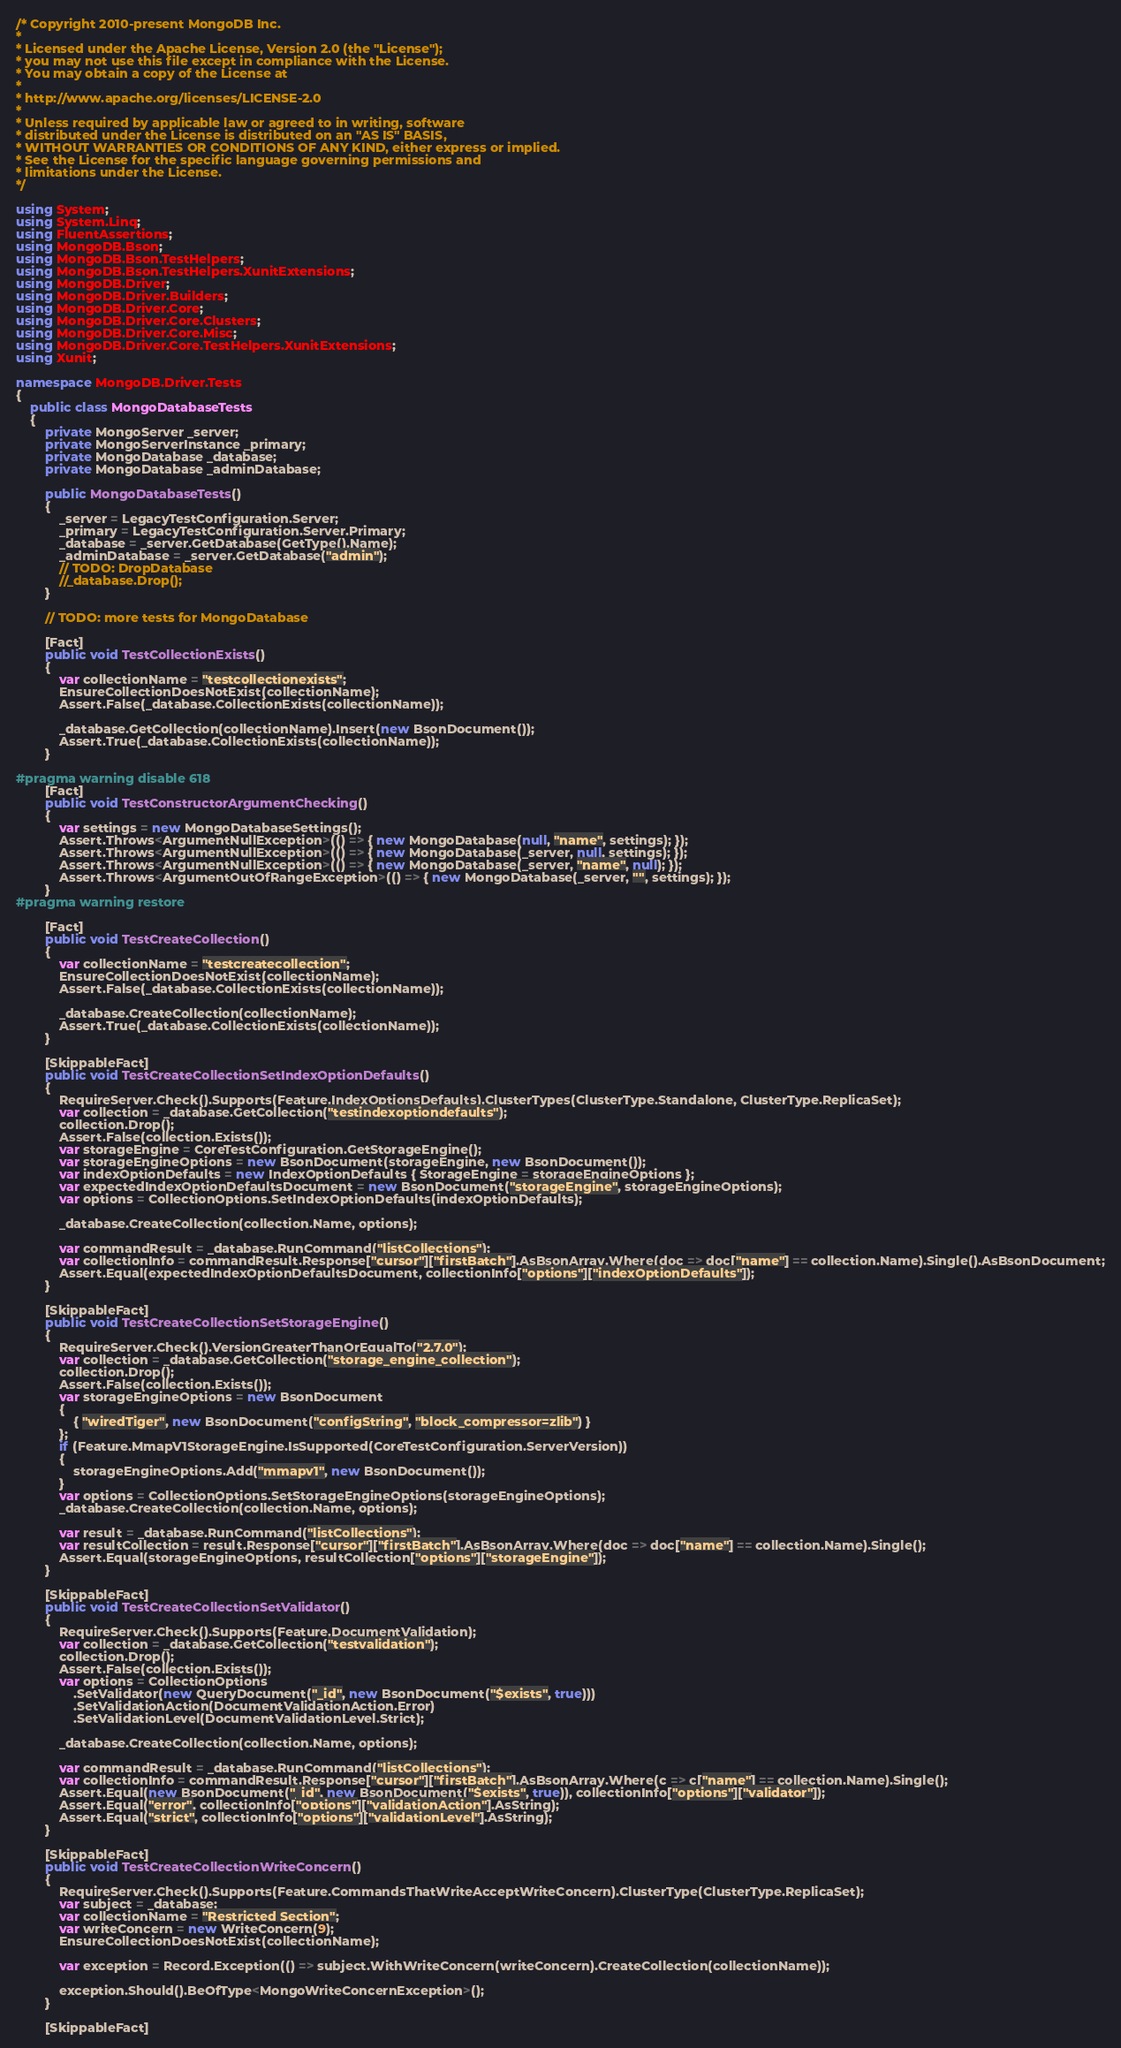Convert code to text. <code><loc_0><loc_0><loc_500><loc_500><_C#_>/* Copyright 2010-present MongoDB Inc.
*
* Licensed under the Apache License, Version 2.0 (the "License");
* you may not use this file except in compliance with the License.
* You may obtain a copy of the License at
*
* http://www.apache.org/licenses/LICENSE-2.0
*
* Unless required by applicable law or agreed to in writing, software
* distributed under the License is distributed on an "AS IS" BASIS,
* WITHOUT WARRANTIES OR CONDITIONS OF ANY KIND, either express or implied.
* See the License for the specific language governing permissions and
* limitations under the License.
*/

using System;
using System.Linq;
using FluentAssertions;
using MongoDB.Bson;
using MongoDB.Bson.TestHelpers;
using MongoDB.Bson.TestHelpers.XunitExtensions;
using MongoDB.Driver;
using MongoDB.Driver.Builders;
using MongoDB.Driver.Core;
using MongoDB.Driver.Core.Clusters;
using MongoDB.Driver.Core.Misc;
using MongoDB.Driver.Core.TestHelpers.XunitExtensions;
using Xunit;

namespace MongoDB.Driver.Tests
{
    public class MongoDatabaseTests
    {
        private MongoServer _server;
        private MongoServerInstance _primary;
        private MongoDatabase _database;
        private MongoDatabase _adminDatabase;

        public MongoDatabaseTests()
        {
            _server = LegacyTestConfiguration.Server;
            _primary = LegacyTestConfiguration.Server.Primary;
            _database = _server.GetDatabase(GetType().Name);
            _adminDatabase = _server.GetDatabase("admin");
            // TODO: DropDatabase
            //_database.Drop();
        }

        // TODO: more tests for MongoDatabase

        [Fact]
        public void TestCollectionExists()
        {
            var collectionName = "testcollectionexists";
            EnsureCollectionDoesNotExist(collectionName);            
            Assert.False(_database.CollectionExists(collectionName));

            _database.GetCollection(collectionName).Insert(new BsonDocument());
            Assert.True(_database.CollectionExists(collectionName));
        }

#pragma warning disable 618
        [Fact]
        public void TestConstructorArgumentChecking()
        {
            var settings = new MongoDatabaseSettings();
            Assert.Throws<ArgumentNullException>(() => { new MongoDatabase(null, "name", settings); });
            Assert.Throws<ArgumentNullException>(() => { new MongoDatabase(_server, null, settings); });
            Assert.Throws<ArgumentNullException>(() => { new MongoDatabase(_server, "name", null); });
            Assert.Throws<ArgumentOutOfRangeException>(() => { new MongoDatabase(_server, "", settings); });
        }
#pragma warning restore

        [Fact]
        public void TestCreateCollection()
        {
            var collectionName = "testcreatecollection";
            EnsureCollectionDoesNotExist(collectionName);
            Assert.False(_database.CollectionExists(collectionName));

            _database.CreateCollection(collectionName);
            Assert.True(_database.CollectionExists(collectionName));
        }

        [SkippableFact]
        public void TestCreateCollectionSetIndexOptionDefaults()
        {
            RequireServer.Check().Supports(Feature.IndexOptionsDefaults).ClusterTypes(ClusterType.Standalone, ClusterType.ReplicaSet);
            var collection = _database.GetCollection("testindexoptiondefaults");
            collection.Drop();
            Assert.False(collection.Exists());
            var storageEngine = CoreTestConfiguration.GetStorageEngine();
            var storageEngineOptions = new BsonDocument(storageEngine, new BsonDocument());
            var indexOptionDefaults = new IndexOptionDefaults { StorageEngine = storageEngineOptions };
            var expectedIndexOptionDefaultsDocument = new BsonDocument("storageEngine", storageEngineOptions);
            var options = CollectionOptions.SetIndexOptionDefaults(indexOptionDefaults);

            _database.CreateCollection(collection.Name, options);

            var commandResult = _database.RunCommand("listCollections");
            var collectionInfo = commandResult.Response["cursor"]["firstBatch"].AsBsonArray.Where(doc => doc["name"] == collection.Name).Single().AsBsonDocument;
            Assert.Equal(expectedIndexOptionDefaultsDocument, collectionInfo["options"]["indexOptionDefaults"]);
        }

        [SkippableFact]
        public void TestCreateCollectionSetStorageEngine()
        {
            RequireServer.Check().VersionGreaterThanOrEqualTo("2.7.0");
            var collection = _database.GetCollection("storage_engine_collection");
            collection.Drop();
            Assert.False(collection.Exists());
            var storageEngineOptions = new BsonDocument
            {
                { "wiredTiger", new BsonDocument("configString", "block_compressor=zlib") }
            };
            if (Feature.MmapV1StorageEngine.IsSupported(CoreTestConfiguration.ServerVersion))
            {
                storageEngineOptions.Add("mmapv1", new BsonDocument());
            }
            var options = CollectionOptions.SetStorageEngineOptions(storageEngineOptions);
            _database.CreateCollection(collection.Name, options);

            var result = _database.RunCommand("listCollections");
            var resultCollection = result.Response["cursor"]["firstBatch"].AsBsonArray.Where(doc => doc["name"] == collection.Name).Single();
            Assert.Equal(storageEngineOptions, resultCollection["options"]["storageEngine"]);
        }

        [SkippableFact]
        public void TestCreateCollectionSetValidator()
        {
            RequireServer.Check().Supports(Feature.DocumentValidation);
            var collection = _database.GetCollection("testvalidation");
            collection.Drop();
            Assert.False(collection.Exists());
            var options = CollectionOptions
                .SetValidator(new QueryDocument("_id", new BsonDocument("$exists", true)))
                .SetValidationAction(DocumentValidationAction.Error)
                .SetValidationLevel(DocumentValidationLevel.Strict);

            _database.CreateCollection(collection.Name, options);

            var commandResult = _database.RunCommand("listCollections");
            var collectionInfo = commandResult.Response["cursor"]["firstBatch"].AsBsonArray.Where(c => c["name"] == collection.Name).Single();
            Assert.Equal(new BsonDocument("_id", new BsonDocument("$exists", true)), collectionInfo["options"]["validator"]);
            Assert.Equal("error", collectionInfo["options"]["validationAction"].AsString);
            Assert.Equal("strict", collectionInfo["options"]["validationLevel"].AsString);
        }

        [SkippableFact]
        public void TestCreateCollectionWriteConcern()
        {
            RequireServer.Check().Supports(Feature.CommandsThatWriteAcceptWriteConcern).ClusterType(ClusterType.ReplicaSet);
            var subject = _database;
            var collectionName = "Restricted Section";
            var writeConcern = new WriteConcern(9);
            EnsureCollectionDoesNotExist(collectionName);

            var exception = Record.Exception(() => subject.WithWriteConcern(writeConcern).CreateCollection(collectionName));

            exception.Should().BeOfType<MongoWriteConcernException>();
        }

        [SkippableFact]</code> 